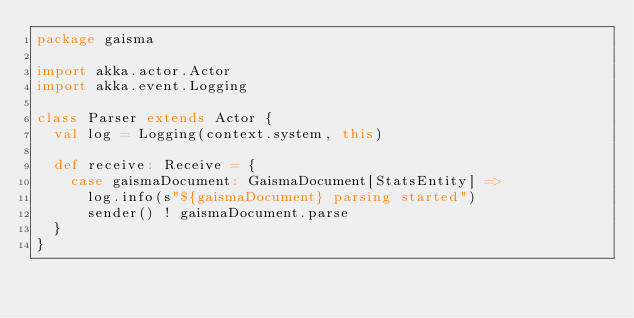Convert code to text. <code><loc_0><loc_0><loc_500><loc_500><_Scala_>package gaisma

import akka.actor.Actor
import akka.event.Logging

class Parser extends Actor {
  val log = Logging(context.system, this)

  def receive: Receive = {
    case gaismaDocument: GaismaDocument[StatsEntity] =>
      log.info(s"${gaismaDocument} parsing started")
      sender() ! gaismaDocument.parse
  }
}</code> 